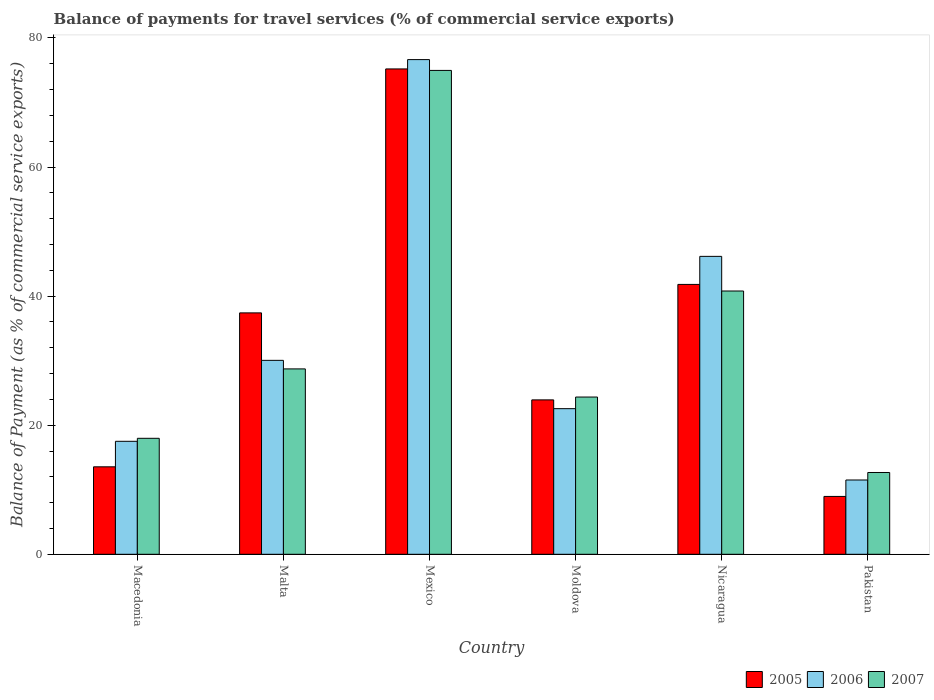How many different coloured bars are there?
Provide a succinct answer. 3. Are the number of bars per tick equal to the number of legend labels?
Your answer should be very brief. Yes. Are the number of bars on each tick of the X-axis equal?
Your response must be concise. Yes. How many bars are there on the 4th tick from the right?
Your response must be concise. 3. What is the balance of payments for travel services in 2006 in Nicaragua?
Offer a very short reply. 46.16. Across all countries, what is the maximum balance of payments for travel services in 2005?
Your answer should be compact. 75.19. Across all countries, what is the minimum balance of payments for travel services in 2006?
Your answer should be compact. 11.51. In which country was the balance of payments for travel services in 2005 maximum?
Ensure brevity in your answer.  Mexico. What is the total balance of payments for travel services in 2006 in the graph?
Ensure brevity in your answer.  204.42. What is the difference between the balance of payments for travel services in 2007 in Malta and that in Pakistan?
Offer a very short reply. 16.05. What is the difference between the balance of payments for travel services in 2006 in Nicaragua and the balance of payments for travel services in 2007 in Mexico?
Provide a short and direct response. -28.81. What is the average balance of payments for travel services in 2007 per country?
Ensure brevity in your answer.  33.25. What is the difference between the balance of payments for travel services of/in 2005 and balance of payments for travel services of/in 2007 in Moldova?
Provide a short and direct response. -0.44. In how many countries, is the balance of payments for travel services in 2006 greater than 8 %?
Ensure brevity in your answer.  6. What is the ratio of the balance of payments for travel services in 2006 in Macedonia to that in Malta?
Your response must be concise. 0.58. Is the balance of payments for travel services in 2007 in Macedonia less than that in Malta?
Your answer should be compact. Yes. Is the difference between the balance of payments for travel services in 2005 in Macedonia and Pakistan greater than the difference between the balance of payments for travel services in 2007 in Macedonia and Pakistan?
Ensure brevity in your answer.  No. What is the difference between the highest and the second highest balance of payments for travel services in 2007?
Your answer should be very brief. -34.18. What is the difference between the highest and the lowest balance of payments for travel services in 2006?
Offer a terse response. 65.13. In how many countries, is the balance of payments for travel services in 2005 greater than the average balance of payments for travel services in 2005 taken over all countries?
Your response must be concise. 3. What does the 1st bar from the right in Moldova represents?
Give a very brief answer. 2007. Is it the case that in every country, the sum of the balance of payments for travel services in 2006 and balance of payments for travel services in 2005 is greater than the balance of payments for travel services in 2007?
Offer a terse response. Yes. How many countries are there in the graph?
Offer a terse response. 6. Where does the legend appear in the graph?
Make the answer very short. Bottom right. How are the legend labels stacked?
Keep it short and to the point. Horizontal. What is the title of the graph?
Offer a terse response. Balance of payments for travel services (% of commercial service exports). Does "1975" appear as one of the legend labels in the graph?
Offer a very short reply. No. What is the label or title of the Y-axis?
Provide a succinct answer. Balance of Payment (as % of commercial service exports). What is the Balance of Payment (as % of commercial service exports) of 2005 in Macedonia?
Your answer should be compact. 13.55. What is the Balance of Payment (as % of commercial service exports) in 2006 in Macedonia?
Offer a very short reply. 17.5. What is the Balance of Payment (as % of commercial service exports) of 2007 in Macedonia?
Your answer should be compact. 17.97. What is the Balance of Payment (as % of commercial service exports) in 2005 in Malta?
Offer a very short reply. 37.4. What is the Balance of Payment (as % of commercial service exports) in 2006 in Malta?
Give a very brief answer. 30.05. What is the Balance of Payment (as % of commercial service exports) in 2007 in Malta?
Give a very brief answer. 28.72. What is the Balance of Payment (as % of commercial service exports) of 2005 in Mexico?
Your response must be concise. 75.19. What is the Balance of Payment (as % of commercial service exports) in 2006 in Mexico?
Your answer should be very brief. 76.64. What is the Balance of Payment (as % of commercial service exports) of 2007 in Mexico?
Offer a terse response. 74.97. What is the Balance of Payment (as % of commercial service exports) of 2005 in Moldova?
Provide a succinct answer. 23.92. What is the Balance of Payment (as % of commercial service exports) of 2006 in Moldova?
Give a very brief answer. 22.56. What is the Balance of Payment (as % of commercial service exports) in 2007 in Moldova?
Offer a very short reply. 24.36. What is the Balance of Payment (as % of commercial service exports) in 2005 in Nicaragua?
Provide a short and direct response. 41.81. What is the Balance of Payment (as % of commercial service exports) of 2006 in Nicaragua?
Your answer should be compact. 46.16. What is the Balance of Payment (as % of commercial service exports) of 2007 in Nicaragua?
Offer a terse response. 40.79. What is the Balance of Payment (as % of commercial service exports) in 2005 in Pakistan?
Provide a short and direct response. 8.97. What is the Balance of Payment (as % of commercial service exports) in 2006 in Pakistan?
Offer a terse response. 11.51. What is the Balance of Payment (as % of commercial service exports) of 2007 in Pakistan?
Your answer should be compact. 12.67. Across all countries, what is the maximum Balance of Payment (as % of commercial service exports) in 2005?
Make the answer very short. 75.19. Across all countries, what is the maximum Balance of Payment (as % of commercial service exports) of 2006?
Make the answer very short. 76.64. Across all countries, what is the maximum Balance of Payment (as % of commercial service exports) of 2007?
Your answer should be compact. 74.97. Across all countries, what is the minimum Balance of Payment (as % of commercial service exports) in 2005?
Offer a very short reply. 8.97. Across all countries, what is the minimum Balance of Payment (as % of commercial service exports) in 2006?
Offer a very short reply. 11.51. Across all countries, what is the minimum Balance of Payment (as % of commercial service exports) in 2007?
Your answer should be very brief. 12.67. What is the total Balance of Payment (as % of commercial service exports) in 2005 in the graph?
Your answer should be very brief. 200.85. What is the total Balance of Payment (as % of commercial service exports) of 2006 in the graph?
Give a very brief answer. 204.42. What is the total Balance of Payment (as % of commercial service exports) of 2007 in the graph?
Your answer should be compact. 199.49. What is the difference between the Balance of Payment (as % of commercial service exports) of 2005 in Macedonia and that in Malta?
Keep it short and to the point. -23.85. What is the difference between the Balance of Payment (as % of commercial service exports) in 2006 in Macedonia and that in Malta?
Offer a terse response. -12.54. What is the difference between the Balance of Payment (as % of commercial service exports) of 2007 in Macedonia and that in Malta?
Provide a short and direct response. -10.75. What is the difference between the Balance of Payment (as % of commercial service exports) in 2005 in Macedonia and that in Mexico?
Keep it short and to the point. -61.64. What is the difference between the Balance of Payment (as % of commercial service exports) of 2006 in Macedonia and that in Mexico?
Provide a short and direct response. -59.14. What is the difference between the Balance of Payment (as % of commercial service exports) of 2007 in Macedonia and that in Mexico?
Your response must be concise. -57. What is the difference between the Balance of Payment (as % of commercial service exports) of 2005 in Macedonia and that in Moldova?
Your answer should be very brief. -10.37. What is the difference between the Balance of Payment (as % of commercial service exports) in 2006 in Macedonia and that in Moldova?
Make the answer very short. -5.06. What is the difference between the Balance of Payment (as % of commercial service exports) of 2007 in Macedonia and that in Moldova?
Your answer should be very brief. -6.39. What is the difference between the Balance of Payment (as % of commercial service exports) of 2005 in Macedonia and that in Nicaragua?
Your answer should be very brief. -28.26. What is the difference between the Balance of Payment (as % of commercial service exports) in 2006 in Macedonia and that in Nicaragua?
Offer a terse response. -28.65. What is the difference between the Balance of Payment (as % of commercial service exports) of 2007 in Macedonia and that in Nicaragua?
Ensure brevity in your answer.  -22.82. What is the difference between the Balance of Payment (as % of commercial service exports) of 2005 in Macedonia and that in Pakistan?
Provide a short and direct response. 4.59. What is the difference between the Balance of Payment (as % of commercial service exports) in 2006 in Macedonia and that in Pakistan?
Give a very brief answer. 5.99. What is the difference between the Balance of Payment (as % of commercial service exports) of 2007 in Macedonia and that in Pakistan?
Give a very brief answer. 5.3. What is the difference between the Balance of Payment (as % of commercial service exports) in 2005 in Malta and that in Mexico?
Make the answer very short. -37.79. What is the difference between the Balance of Payment (as % of commercial service exports) of 2006 in Malta and that in Mexico?
Provide a succinct answer. -46.59. What is the difference between the Balance of Payment (as % of commercial service exports) of 2007 in Malta and that in Mexico?
Your response must be concise. -46.24. What is the difference between the Balance of Payment (as % of commercial service exports) in 2005 in Malta and that in Moldova?
Ensure brevity in your answer.  13.48. What is the difference between the Balance of Payment (as % of commercial service exports) of 2006 in Malta and that in Moldova?
Provide a short and direct response. 7.48. What is the difference between the Balance of Payment (as % of commercial service exports) in 2007 in Malta and that in Moldova?
Your answer should be compact. 4.36. What is the difference between the Balance of Payment (as % of commercial service exports) of 2005 in Malta and that in Nicaragua?
Offer a terse response. -4.41. What is the difference between the Balance of Payment (as % of commercial service exports) of 2006 in Malta and that in Nicaragua?
Offer a very short reply. -16.11. What is the difference between the Balance of Payment (as % of commercial service exports) in 2007 in Malta and that in Nicaragua?
Your answer should be compact. -12.07. What is the difference between the Balance of Payment (as % of commercial service exports) of 2005 in Malta and that in Pakistan?
Your answer should be very brief. 28.43. What is the difference between the Balance of Payment (as % of commercial service exports) of 2006 in Malta and that in Pakistan?
Provide a succinct answer. 18.53. What is the difference between the Balance of Payment (as % of commercial service exports) in 2007 in Malta and that in Pakistan?
Provide a succinct answer. 16.05. What is the difference between the Balance of Payment (as % of commercial service exports) of 2005 in Mexico and that in Moldova?
Offer a very short reply. 51.27. What is the difference between the Balance of Payment (as % of commercial service exports) in 2006 in Mexico and that in Moldova?
Give a very brief answer. 54.08. What is the difference between the Balance of Payment (as % of commercial service exports) of 2007 in Mexico and that in Moldova?
Ensure brevity in your answer.  50.6. What is the difference between the Balance of Payment (as % of commercial service exports) in 2005 in Mexico and that in Nicaragua?
Your response must be concise. 33.38. What is the difference between the Balance of Payment (as % of commercial service exports) of 2006 in Mexico and that in Nicaragua?
Keep it short and to the point. 30.48. What is the difference between the Balance of Payment (as % of commercial service exports) in 2007 in Mexico and that in Nicaragua?
Your answer should be very brief. 34.18. What is the difference between the Balance of Payment (as % of commercial service exports) in 2005 in Mexico and that in Pakistan?
Provide a succinct answer. 66.23. What is the difference between the Balance of Payment (as % of commercial service exports) of 2006 in Mexico and that in Pakistan?
Provide a succinct answer. 65.13. What is the difference between the Balance of Payment (as % of commercial service exports) in 2007 in Mexico and that in Pakistan?
Your response must be concise. 62.29. What is the difference between the Balance of Payment (as % of commercial service exports) in 2005 in Moldova and that in Nicaragua?
Keep it short and to the point. -17.89. What is the difference between the Balance of Payment (as % of commercial service exports) of 2006 in Moldova and that in Nicaragua?
Offer a very short reply. -23.59. What is the difference between the Balance of Payment (as % of commercial service exports) of 2007 in Moldova and that in Nicaragua?
Offer a terse response. -16.43. What is the difference between the Balance of Payment (as % of commercial service exports) of 2005 in Moldova and that in Pakistan?
Your answer should be compact. 14.96. What is the difference between the Balance of Payment (as % of commercial service exports) in 2006 in Moldova and that in Pakistan?
Your answer should be compact. 11.05. What is the difference between the Balance of Payment (as % of commercial service exports) in 2007 in Moldova and that in Pakistan?
Provide a succinct answer. 11.69. What is the difference between the Balance of Payment (as % of commercial service exports) of 2005 in Nicaragua and that in Pakistan?
Offer a very short reply. 32.85. What is the difference between the Balance of Payment (as % of commercial service exports) in 2006 in Nicaragua and that in Pakistan?
Offer a terse response. 34.64. What is the difference between the Balance of Payment (as % of commercial service exports) in 2007 in Nicaragua and that in Pakistan?
Make the answer very short. 28.12. What is the difference between the Balance of Payment (as % of commercial service exports) in 2005 in Macedonia and the Balance of Payment (as % of commercial service exports) in 2006 in Malta?
Your response must be concise. -16.49. What is the difference between the Balance of Payment (as % of commercial service exports) of 2005 in Macedonia and the Balance of Payment (as % of commercial service exports) of 2007 in Malta?
Your answer should be compact. -15.17. What is the difference between the Balance of Payment (as % of commercial service exports) in 2006 in Macedonia and the Balance of Payment (as % of commercial service exports) in 2007 in Malta?
Your response must be concise. -11.22. What is the difference between the Balance of Payment (as % of commercial service exports) in 2005 in Macedonia and the Balance of Payment (as % of commercial service exports) in 2006 in Mexico?
Your response must be concise. -63.09. What is the difference between the Balance of Payment (as % of commercial service exports) of 2005 in Macedonia and the Balance of Payment (as % of commercial service exports) of 2007 in Mexico?
Keep it short and to the point. -61.41. What is the difference between the Balance of Payment (as % of commercial service exports) in 2006 in Macedonia and the Balance of Payment (as % of commercial service exports) in 2007 in Mexico?
Offer a terse response. -57.46. What is the difference between the Balance of Payment (as % of commercial service exports) in 2005 in Macedonia and the Balance of Payment (as % of commercial service exports) in 2006 in Moldova?
Make the answer very short. -9.01. What is the difference between the Balance of Payment (as % of commercial service exports) of 2005 in Macedonia and the Balance of Payment (as % of commercial service exports) of 2007 in Moldova?
Your response must be concise. -10.81. What is the difference between the Balance of Payment (as % of commercial service exports) in 2006 in Macedonia and the Balance of Payment (as % of commercial service exports) in 2007 in Moldova?
Provide a short and direct response. -6.86. What is the difference between the Balance of Payment (as % of commercial service exports) in 2005 in Macedonia and the Balance of Payment (as % of commercial service exports) in 2006 in Nicaragua?
Ensure brevity in your answer.  -32.6. What is the difference between the Balance of Payment (as % of commercial service exports) in 2005 in Macedonia and the Balance of Payment (as % of commercial service exports) in 2007 in Nicaragua?
Make the answer very short. -27.24. What is the difference between the Balance of Payment (as % of commercial service exports) in 2006 in Macedonia and the Balance of Payment (as % of commercial service exports) in 2007 in Nicaragua?
Your answer should be compact. -23.29. What is the difference between the Balance of Payment (as % of commercial service exports) in 2005 in Macedonia and the Balance of Payment (as % of commercial service exports) in 2006 in Pakistan?
Make the answer very short. 2.04. What is the difference between the Balance of Payment (as % of commercial service exports) in 2005 in Macedonia and the Balance of Payment (as % of commercial service exports) in 2007 in Pakistan?
Your answer should be compact. 0.88. What is the difference between the Balance of Payment (as % of commercial service exports) of 2006 in Macedonia and the Balance of Payment (as % of commercial service exports) of 2007 in Pakistan?
Give a very brief answer. 4.83. What is the difference between the Balance of Payment (as % of commercial service exports) in 2005 in Malta and the Balance of Payment (as % of commercial service exports) in 2006 in Mexico?
Provide a short and direct response. -39.24. What is the difference between the Balance of Payment (as % of commercial service exports) of 2005 in Malta and the Balance of Payment (as % of commercial service exports) of 2007 in Mexico?
Give a very brief answer. -37.57. What is the difference between the Balance of Payment (as % of commercial service exports) in 2006 in Malta and the Balance of Payment (as % of commercial service exports) in 2007 in Mexico?
Your answer should be compact. -44.92. What is the difference between the Balance of Payment (as % of commercial service exports) of 2005 in Malta and the Balance of Payment (as % of commercial service exports) of 2006 in Moldova?
Your response must be concise. 14.84. What is the difference between the Balance of Payment (as % of commercial service exports) in 2005 in Malta and the Balance of Payment (as % of commercial service exports) in 2007 in Moldova?
Offer a terse response. 13.04. What is the difference between the Balance of Payment (as % of commercial service exports) in 2006 in Malta and the Balance of Payment (as % of commercial service exports) in 2007 in Moldova?
Offer a very short reply. 5.68. What is the difference between the Balance of Payment (as % of commercial service exports) in 2005 in Malta and the Balance of Payment (as % of commercial service exports) in 2006 in Nicaragua?
Keep it short and to the point. -8.76. What is the difference between the Balance of Payment (as % of commercial service exports) in 2005 in Malta and the Balance of Payment (as % of commercial service exports) in 2007 in Nicaragua?
Provide a short and direct response. -3.39. What is the difference between the Balance of Payment (as % of commercial service exports) in 2006 in Malta and the Balance of Payment (as % of commercial service exports) in 2007 in Nicaragua?
Keep it short and to the point. -10.74. What is the difference between the Balance of Payment (as % of commercial service exports) in 2005 in Malta and the Balance of Payment (as % of commercial service exports) in 2006 in Pakistan?
Your answer should be very brief. 25.89. What is the difference between the Balance of Payment (as % of commercial service exports) in 2005 in Malta and the Balance of Payment (as % of commercial service exports) in 2007 in Pakistan?
Provide a succinct answer. 24.73. What is the difference between the Balance of Payment (as % of commercial service exports) in 2006 in Malta and the Balance of Payment (as % of commercial service exports) in 2007 in Pakistan?
Give a very brief answer. 17.37. What is the difference between the Balance of Payment (as % of commercial service exports) of 2005 in Mexico and the Balance of Payment (as % of commercial service exports) of 2006 in Moldova?
Your answer should be compact. 52.63. What is the difference between the Balance of Payment (as % of commercial service exports) of 2005 in Mexico and the Balance of Payment (as % of commercial service exports) of 2007 in Moldova?
Offer a very short reply. 50.83. What is the difference between the Balance of Payment (as % of commercial service exports) in 2006 in Mexico and the Balance of Payment (as % of commercial service exports) in 2007 in Moldova?
Offer a terse response. 52.28. What is the difference between the Balance of Payment (as % of commercial service exports) of 2005 in Mexico and the Balance of Payment (as % of commercial service exports) of 2006 in Nicaragua?
Your answer should be very brief. 29.04. What is the difference between the Balance of Payment (as % of commercial service exports) of 2005 in Mexico and the Balance of Payment (as % of commercial service exports) of 2007 in Nicaragua?
Your answer should be compact. 34.4. What is the difference between the Balance of Payment (as % of commercial service exports) in 2006 in Mexico and the Balance of Payment (as % of commercial service exports) in 2007 in Nicaragua?
Your answer should be very brief. 35.85. What is the difference between the Balance of Payment (as % of commercial service exports) in 2005 in Mexico and the Balance of Payment (as % of commercial service exports) in 2006 in Pakistan?
Make the answer very short. 63.68. What is the difference between the Balance of Payment (as % of commercial service exports) of 2005 in Mexico and the Balance of Payment (as % of commercial service exports) of 2007 in Pakistan?
Provide a succinct answer. 62.52. What is the difference between the Balance of Payment (as % of commercial service exports) of 2006 in Mexico and the Balance of Payment (as % of commercial service exports) of 2007 in Pakistan?
Your answer should be compact. 63.97. What is the difference between the Balance of Payment (as % of commercial service exports) in 2005 in Moldova and the Balance of Payment (as % of commercial service exports) in 2006 in Nicaragua?
Your response must be concise. -22.23. What is the difference between the Balance of Payment (as % of commercial service exports) in 2005 in Moldova and the Balance of Payment (as % of commercial service exports) in 2007 in Nicaragua?
Provide a succinct answer. -16.87. What is the difference between the Balance of Payment (as % of commercial service exports) in 2006 in Moldova and the Balance of Payment (as % of commercial service exports) in 2007 in Nicaragua?
Keep it short and to the point. -18.23. What is the difference between the Balance of Payment (as % of commercial service exports) in 2005 in Moldova and the Balance of Payment (as % of commercial service exports) in 2006 in Pakistan?
Offer a terse response. 12.41. What is the difference between the Balance of Payment (as % of commercial service exports) in 2005 in Moldova and the Balance of Payment (as % of commercial service exports) in 2007 in Pakistan?
Make the answer very short. 11.25. What is the difference between the Balance of Payment (as % of commercial service exports) of 2006 in Moldova and the Balance of Payment (as % of commercial service exports) of 2007 in Pakistan?
Offer a very short reply. 9.89. What is the difference between the Balance of Payment (as % of commercial service exports) in 2005 in Nicaragua and the Balance of Payment (as % of commercial service exports) in 2006 in Pakistan?
Provide a short and direct response. 30.3. What is the difference between the Balance of Payment (as % of commercial service exports) of 2005 in Nicaragua and the Balance of Payment (as % of commercial service exports) of 2007 in Pakistan?
Offer a terse response. 29.14. What is the difference between the Balance of Payment (as % of commercial service exports) of 2006 in Nicaragua and the Balance of Payment (as % of commercial service exports) of 2007 in Pakistan?
Keep it short and to the point. 33.48. What is the average Balance of Payment (as % of commercial service exports) in 2005 per country?
Ensure brevity in your answer.  33.47. What is the average Balance of Payment (as % of commercial service exports) of 2006 per country?
Your answer should be very brief. 34.07. What is the average Balance of Payment (as % of commercial service exports) of 2007 per country?
Your answer should be very brief. 33.25. What is the difference between the Balance of Payment (as % of commercial service exports) in 2005 and Balance of Payment (as % of commercial service exports) in 2006 in Macedonia?
Offer a very short reply. -3.95. What is the difference between the Balance of Payment (as % of commercial service exports) of 2005 and Balance of Payment (as % of commercial service exports) of 2007 in Macedonia?
Your answer should be very brief. -4.42. What is the difference between the Balance of Payment (as % of commercial service exports) of 2006 and Balance of Payment (as % of commercial service exports) of 2007 in Macedonia?
Keep it short and to the point. -0.47. What is the difference between the Balance of Payment (as % of commercial service exports) in 2005 and Balance of Payment (as % of commercial service exports) in 2006 in Malta?
Ensure brevity in your answer.  7.35. What is the difference between the Balance of Payment (as % of commercial service exports) of 2005 and Balance of Payment (as % of commercial service exports) of 2007 in Malta?
Offer a very short reply. 8.68. What is the difference between the Balance of Payment (as % of commercial service exports) in 2006 and Balance of Payment (as % of commercial service exports) in 2007 in Malta?
Provide a succinct answer. 1.32. What is the difference between the Balance of Payment (as % of commercial service exports) of 2005 and Balance of Payment (as % of commercial service exports) of 2006 in Mexico?
Keep it short and to the point. -1.45. What is the difference between the Balance of Payment (as % of commercial service exports) of 2005 and Balance of Payment (as % of commercial service exports) of 2007 in Mexico?
Provide a succinct answer. 0.23. What is the difference between the Balance of Payment (as % of commercial service exports) in 2006 and Balance of Payment (as % of commercial service exports) in 2007 in Mexico?
Your response must be concise. 1.67. What is the difference between the Balance of Payment (as % of commercial service exports) in 2005 and Balance of Payment (as % of commercial service exports) in 2006 in Moldova?
Ensure brevity in your answer.  1.36. What is the difference between the Balance of Payment (as % of commercial service exports) of 2005 and Balance of Payment (as % of commercial service exports) of 2007 in Moldova?
Your response must be concise. -0.44. What is the difference between the Balance of Payment (as % of commercial service exports) in 2006 and Balance of Payment (as % of commercial service exports) in 2007 in Moldova?
Your answer should be very brief. -1.8. What is the difference between the Balance of Payment (as % of commercial service exports) in 2005 and Balance of Payment (as % of commercial service exports) in 2006 in Nicaragua?
Your response must be concise. -4.34. What is the difference between the Balance of Payment (as % of commercial service exports) of 2005 and Balance of Payment (as % of commercial service exports) of 2007 in Nicaragua?
Offer a very short reply. 1.02. What is the difference between the Balance of Payment (as % of commercial service exports) of 2006 and Balance of Payment (as % of commercial service exports) of 2007 in Nicaragua?
Offer a very short reply. 5.37. What is the difference between the Balance of Payment (as % of commercial service exports) of 2005 and Balance of Payment (as % of commercial service exports) of 2006 in Pakistan?
Provide a succinct answer. -2.55. What is the difference between the Balance of Payment (as % of commercial service exports) in 2005 and Balance of Payment (as % of commercial service exports) in 2007 in Pakistan?
Provide a short and direct response. -3.71. What is the difference between the Balance of Payment (as % of commercial service exports) of 2006 and Balance of Payment (as % of commercial service exports) of 2007 in Pakistan?
Keep it short and to the point. -1.16. What is the ratio of the Balance of Payment (as % of commercial service exports) of 2005 in Macedonia to that in Malta?
Provide a short and direct response. 0.36. What is the ratio of the Balance of Payment (as % of commercial service exports) of 2006 in Macedonia to that in Malta?
Offer a terse response. 0.58. What is the ratio of the Balance of Payment (as % of commercial service exports) of 2007 in Macedonia to that in Malta?
Offer a very short reply. 0.63. What is the ratio of the Balance of Payment (as % of commercial service exports) in 2005 in Macedonia to that in Mexico?
Provide a short and direct response. 0.18. What is the ratio of the Balance of Payment (as % of commercial service exports) of 2006 in Macedonia to that in Mexico?
Provide a succinct answer. 0.23. What is the ratio of the Balance of Payment (as % of commercial service exports) in 2007 in Macedonia to that in Mexico?
Your answer should be compact. 0.24. What is the ratio of the Balance of Payment (as % of commercial service exports) of 2005 in Macedonia to that in Moldova?
Give a very brief answer. 0.57. What is the ratio of the Balance of Payment (as % of commercial service exports) of 2006 in Macedonia to that in Moldova?
Give a very brief answer. 0.78. What is the ratio of the Balance of Payment (as % of commercial service exports) in 2007 in Macedonia to that in Moldova?
Keep it short and to the point. 0.74. What is the ratio of the Balance of Payment (as % of commercial service exports) of 2005 in Macedonia to that in Nicaragua?
Give a very brief answer. 0.32. What is the ratio of the Balance of Payment (as % of commercial service exports) of 2006 in Macedonia to that in Nicaragua?
Your response must be concise. 0.38. What is the ratio of the Balance of Payment (as % of commercial service exports) in 2007 in Macedonia to that in Nicaragua?
Provide a succinct answer. 0.44. What is the ratio of the Balance of Payment (as % of commercial service exports) in 2005 in Macedonia to that in Pakistan?
Provide a succinct answer. 1.51. What is the ratio of the Balance of Payment (as % of commercial service exports) of 2006 in Macedonia to that in Pakistan?
Provide a short and direct response. 1.52. What is the ratio of the Balance of Payment (as % of commercial service exports) in 2007 in Macedonia to that in Pakistan?
Your response must be concise. 1.42. What is the ratio of the Balance of Payment (as % of commercial service exports) in 2005 in Malta to that in Mexico?
Provide a succinct answer. 0.5. What is the ratio of the Balance of Payment (as % of commercial service exports) of 2006 in Malta to that in Mexico?
Keep it short and to the point. 0.39. What is the ratio of the Balance of Payment (as % of commercial service exports) in 2007 in Malta to that in Mexico?
Keep it short and to the point. 0.38. What is the ratio of the Balance of Payment (as % of commercial service exports) of 2005 in Malta to that in Moldova?
Give a very brief answer. 1.56. What is the ratio of the Balance of Payment (as % of commercial service exports) in 2006 in Malta to that in Moldova?
Offer a very short reply. 1.33. What is the ratio of the Balance of Payment (as % of commercial service exports) in 2007 in Malta to that in Moldova?
Offer a terse response. 1.18. What is the ratio of the Balance of Payment (as % of commercial service exports) in 2005 in Malta to that in Nicaragua?
Keep it short and to the point. 0.89. What is the ratio of the Balance of Payment (as % of commercial service exports) in 2006 in Malta to that in Nicaragua?
Offer a terse response. 0.65. What is the ratio of the Balance of Payment (as % of commercial service exports) of 2007 in Malta to that in Nicaragua?
Make the answer very short. 0.7. What is the ratio of the Balance of Payment (as % of commercial service exports) of 2005 in Malta to that in Pakistan?
Your answer should be compact. 4.17. What is the ratio of the Balance of Payment (as % of commercial service exports) of 2006 in Malta to that in Pakistan?
Ensure brevity in your answer.  2.61. What is the ratio of the Balance of Payment (as % of commercial service exports) of 2007 in Malta to that in Pakistan?
Keep it short and to the point. 2.27. What is the ratio of the Balance of Payment (as % of commercial service exports) of 2005 in Mexico to that in Moldova?
Offer a terse response. 3.14. What is the ratio of the Balance of Payment (as % of commercial service exports) of 2006 in Mexico to that in Moldova?
Provide a short and direct response. 3.4. What is the ratio of the Balance of Payment (as % of commercial service exports) of 2007 in Mexico to that in Moldova?
Your response must be concise. 3.08. What is the ratio of the Balance of Payment (as % of commercial service exports) of 2005 in Mexico to that in Nicaragua?
Offer a very short reply. 1.8. What is the ratio of the Balance of Payment (as % of commercial service exports) of 2006 in Mexico to that in Nicaragua?
Your answer should be very brief. 1.66. What is the ratio of the Balance of Payment (as % of commercial service exports) in 2007 in Mexico to that in Nicaragua?
Give a very brief answer. 1.84. What is the ratio of the Balance of Payment (as % of commercial service exports) in 2005 in Mexico to that in Pakistan?
Offer a very short reply. 8.39. What is the ratio of the Balance of Payment (as % of commercial service exports) of 2006 in Mexico to that in Pakistan?
Your answer should be very brief. 6.66. What is the ratio of the Balance of Payment (as % of commercial service exports) of 2007 in Mexico to that in Pakistan?
Your answer should be compact. 5.92. What is the ratio of the Balance of Payment (as % of commercial service exports) in 2005 in Moldova to that in Nicaragua?
Offer a very short reply. 0.57. What is the ratio of the Balance of Payment (as % of commercial service exports) of 2006 in Moldova to that in Nicaragua?
Your answer should be very brief. 0.49. What is the ratio of the Balance of Payment (as % of commercial service exports) of 2007 in Moldova to that in Nicaragua?
Provide a short and direct response. 0.6. What is the ratio of the Balance of Payment (as % of commercial service exports) in 2005 in Moldova to that in Pakistan?
Keep it short and to the point. 2.67. What is the ratio of the Balance of Payment (as % of commercial service exports) of 2006 in Moldova to that in Pakistan?
Your answer should be compact. 1.96. What is the ratio of the Balance of Payment (as % of commercial service exports) of 2007 in Moldova to that in Pakistan?
Your response must be concise. 1.92. What is the ratio of the Balance of Payment (as % of commercial service exports) in 2005 in Nicaragua to that in Pakistan?
Keep it short and to the point. 4.66. What is the ratio of the Balance of Payment (as % of commercial service exports) of 2006 in Nicaragua to that in Pakistan?
Your answer should be very brief. 4.01. What is the ratio of the Balance of Payment (as % of commercial service exports) of 2007 in Nicaragua to that in Pakistan?
Your response must be concise. 3.22. What is the difference between the highest and the second highest Balance of Payment (as % of commercial service exports) in 2005?
Provide a short and direct response. 33.38. What is the difference between the highest and the second highest Balance of Payment (as % of commercial service exports) of 2006?
Offer a terse response. 30.48. What is the difference between the highest and the second highest Balance of Payment (as % of commercial service exports) of 2007?
Ensure brevity in your answer.  34.18. What is the difference between the highest and the lowest Balance of Payment (as % of commercial service exports) of 2005?
Keep it short and to the point. 66.23. What is the difference between the highest and the lowest Balance of Payment (as % of commercial service exports) in 2006?
Keep it short and to the point. 65.13. What is the difference between the highest and the lowest Balance of Payment (as % of commercial service exports) in 2007?
Your answer should be compact. 62.29. 